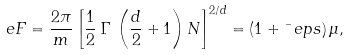Convert formula to latex. <formula><loc_0><loc_0><loc_500><loc_500>\ e F = \frac { 2 \pi } m \left [ \frac { 1 } { 2 } \, \Gamma \, \left ( \frac { d } { 2 } + 1 \right ) N \right ] ^ { 2 / d } = \left ( 1 + \bar { \ } e p s \right ) \mu ,</formula> 